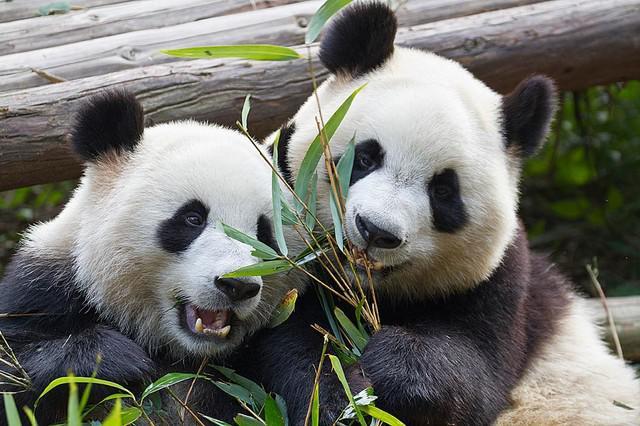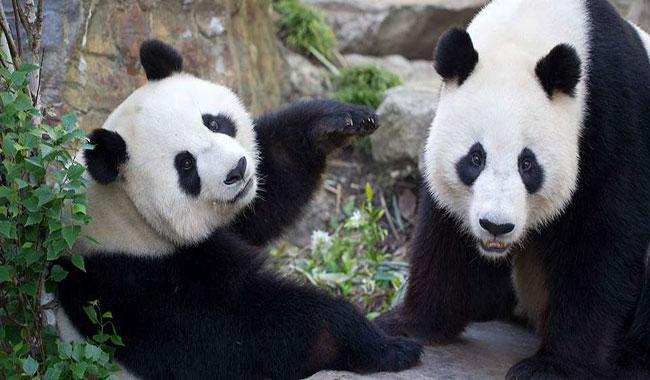The first image is the image on the left, the second image is the image on the right. Considering the images on both sides, is "The left and right image contains the same number of pandas sitting next to each other." valid? Answer yes or no. Yes. The first image is the image on the left, the second image is the image on the right. Considering the images on both sides, is "In one image, two pandas are sitting close together with at least one of them clutching a green stalk, and the other image shows two pandas with their bodies facing." valid? Answer yes or no. Yes. 